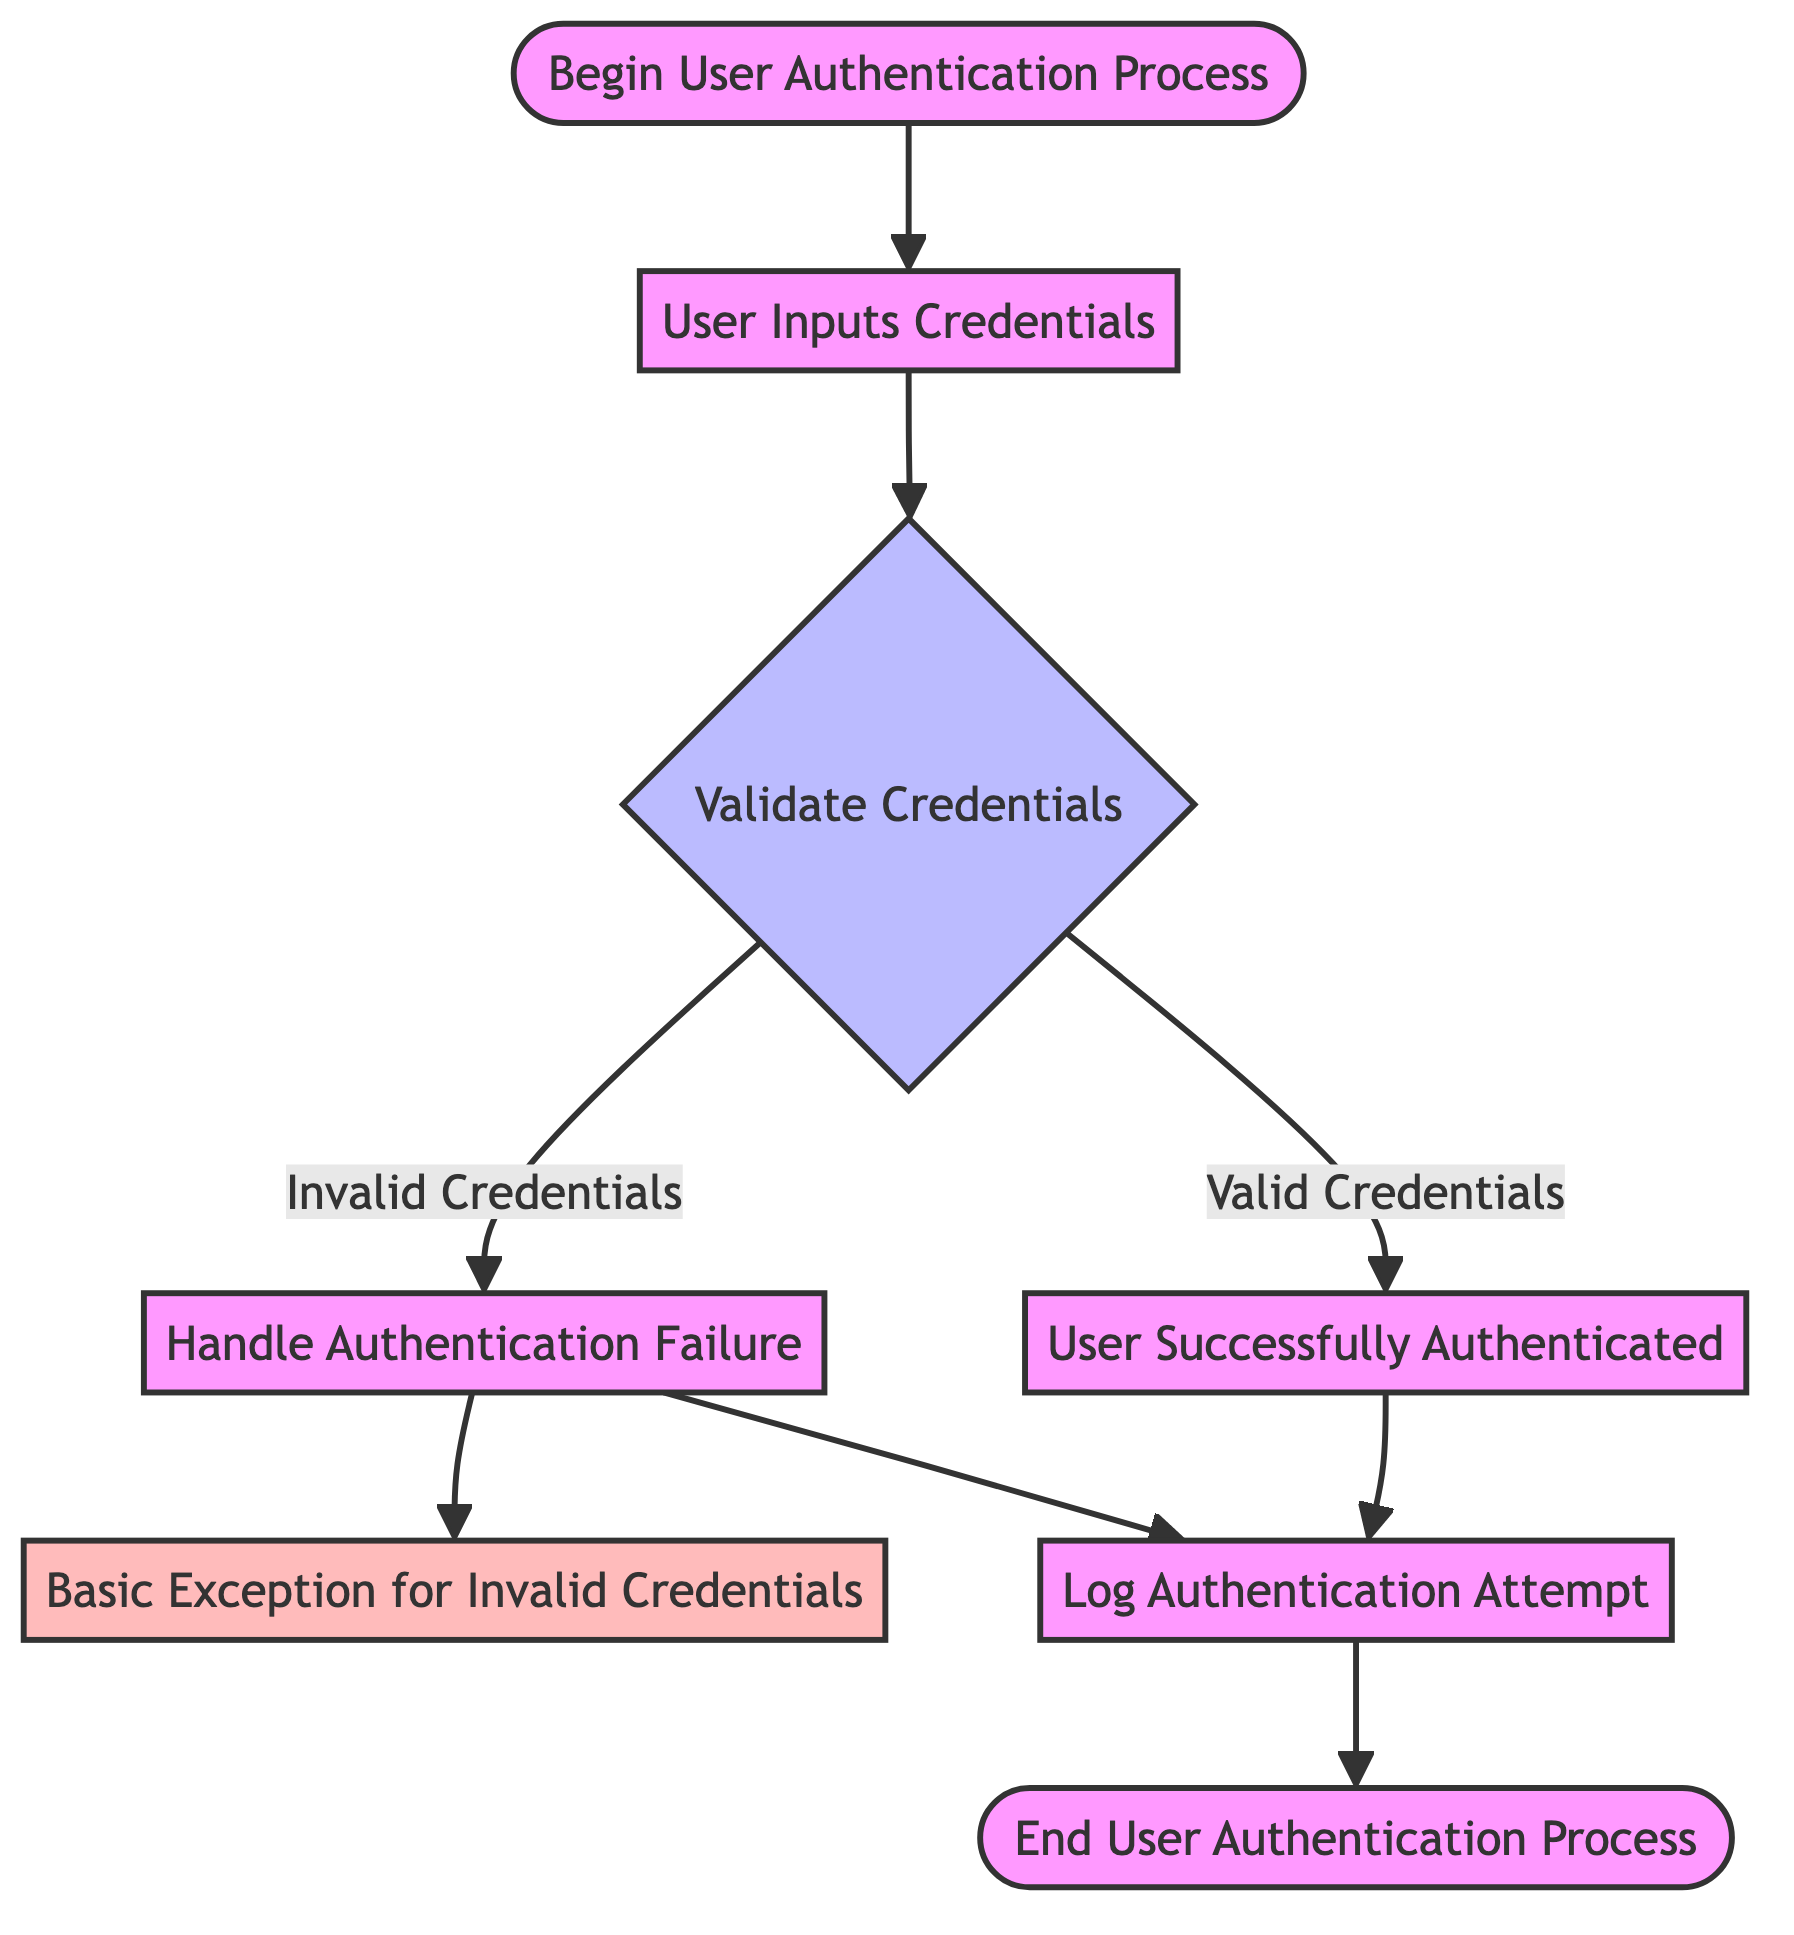What is the first step in the user authentication process? The first step is represented by the node labeled "Start," which indicates the beginning of the user authentication process.
Answer: Begin User Authentication Process How many decision nodes are present in this diagram? There is a single decision node in the diagram, labeled as "Validate Credentials." It checks whether the provided credentials are valid or invalid.
Answer: 1 What happens after a user is successfully authenticated? After successful authentication, the process moves to the node labeled "Log Authentication Attempt," where the attempt is logged for future reference.
Answer: Log Authentication Attempt What is the outcome if the credentials are invalid? If the credentials are invalid, the flow transitions to the node labeled "Authentication Failed," indicating that the authentication attempt has not succeeded.
Answer: Authentication Failed What exception is raised for invalid credentials? The exception that is raised when invalid credentials are provided is labeled "Basic Exception for Invalid Credentials." This indicates a general failure in the authentication process.
Answer: Basic Exception for Invalid Credentials Which nodes connect directly to "Log Authentication Attempt"? The "Log Authentication Attempt" node connects directly from both "Successful Authentication" and "Authentication Failed," meaning it is executed in both scenarios.
Answer: Successful Authentication, Authentication Failed What is the last step in the user authentication process? The final step in the diagram is represented by the node labeled "End," which signifies the conclusion of the user authentication process.
Answer: End User Authentication Process 